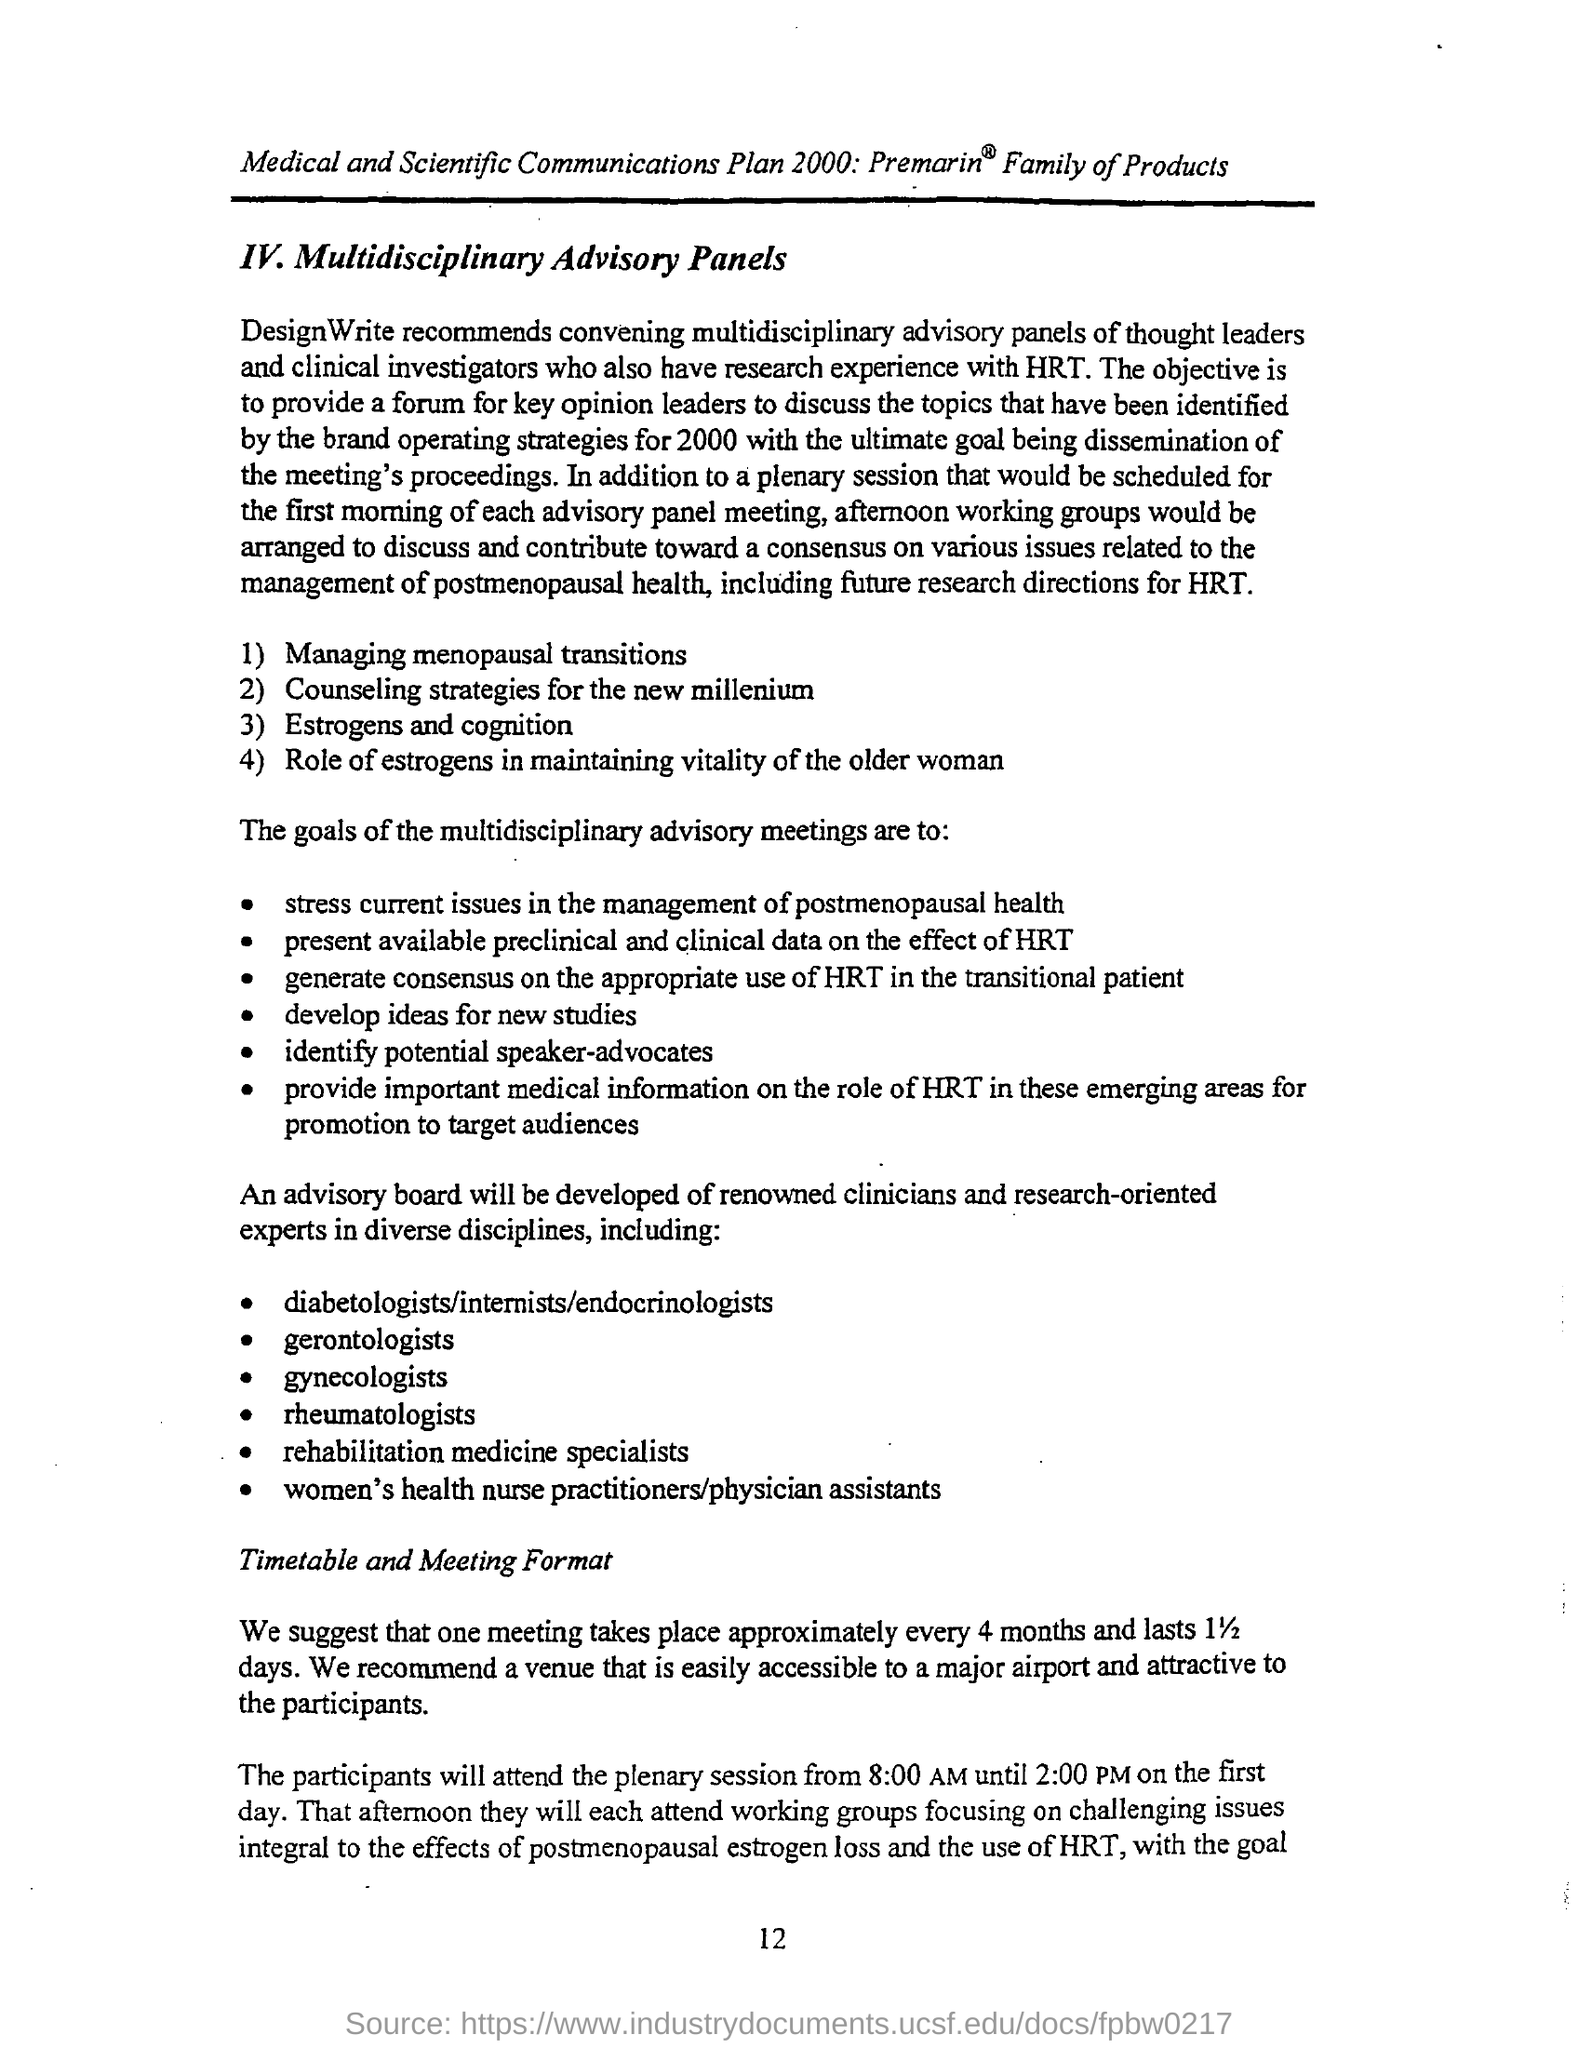Outline some significant characteristics in this image. A meeting shall be held every 4 months and shall last for 11/2 days. The speaker is inquiring about the page number of a document. They provide a range of numbers, specifically "12," to indicate their uncertainty. 